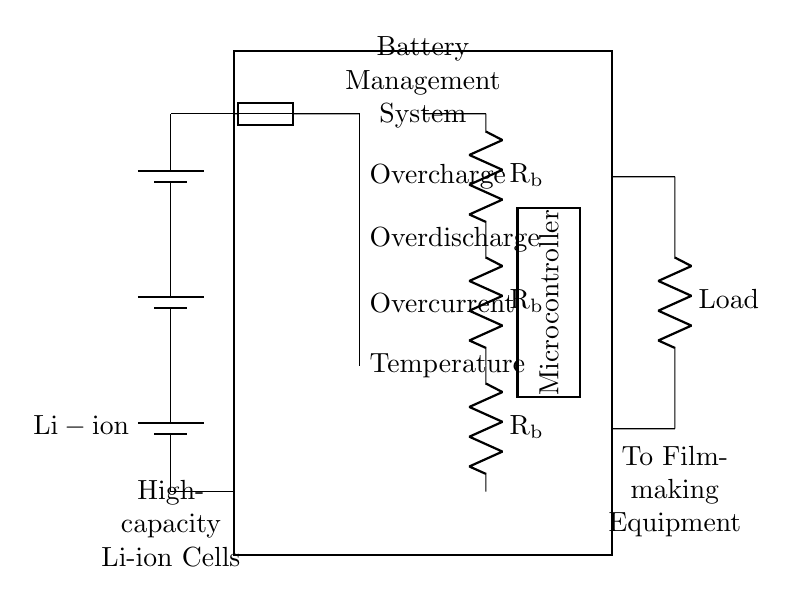What type of battery is used? The circuit diagram labels the battery as "Li-ion," indicating that lithium-ion cells are used.
Answer: Li-ion What does the fuse protect against? The fuse in the circuit provides protection against overcurrent, which is a situation where the current exceeds a safe limit, potentially causing damage.
Answer: Overcurrent How many resistors are present in the circuit? The circuit contains three resistors labeled as Rb, which are part of the balancing circuit. Counting these provides the answer.
Answer: 3 What is the function of the microcontroller? The microcontroller is responsible for managing various aspects of the battery management system, including monitoring and controlling charging and discharging processes, ensuring safe operation.
Answer: Management What type of protection does the circuitry provide? The protection circuitry includes measures against overcharge, overdischarge, overcurrent, and temperature, which help maintain the safety and longevity of the batteries.
Answer: Four types What is the output of the system connected to? The output of the system is connected to the "Load," which indicates it provides power to the filmmaking equipment requiring electricity from the battery management system.
Answer: Filmmaking Equipment 